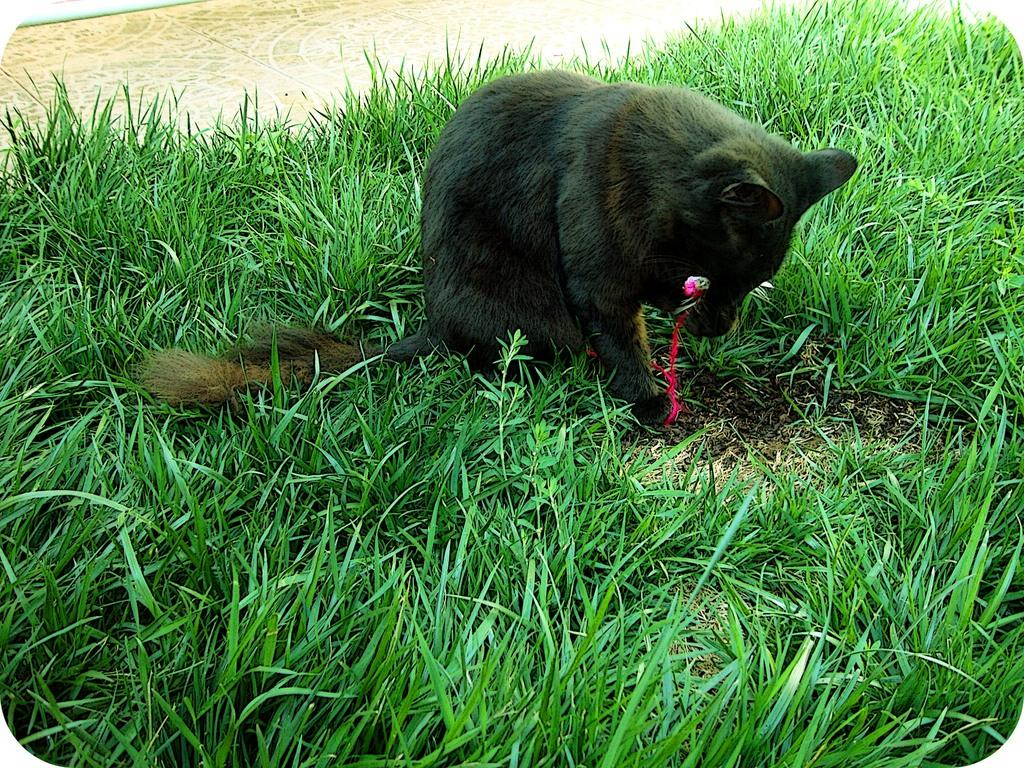What type of animal is in the image? There is a black cat in the image. Where is the black cat located? The black cat is on the grass. What direction is the wind blowing in the image? There is no mention of wind in the image, so it cannot be determined from the image. 